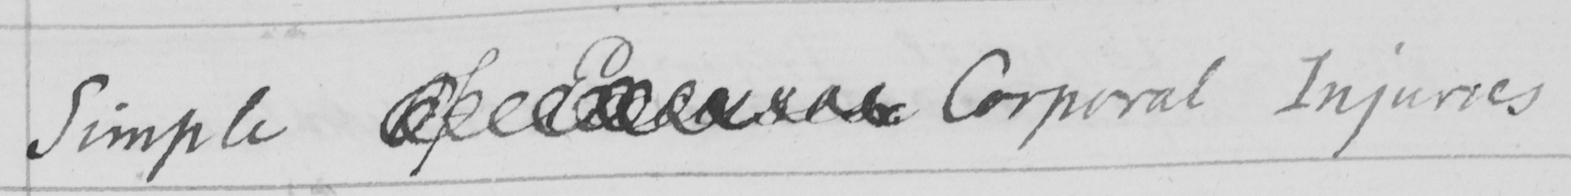What does this handwritten line say? Simple  <gap/>  Corporal Injuries 